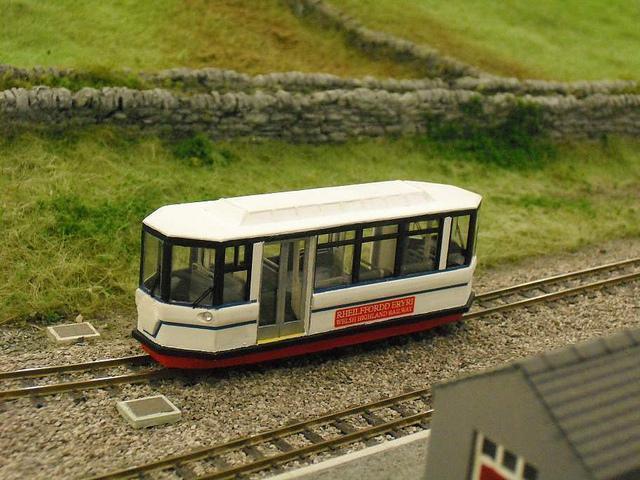How many trains are visible?
Give a very brief answer. 1. How many dogs do you see?
Give a very brief answer. 0. 